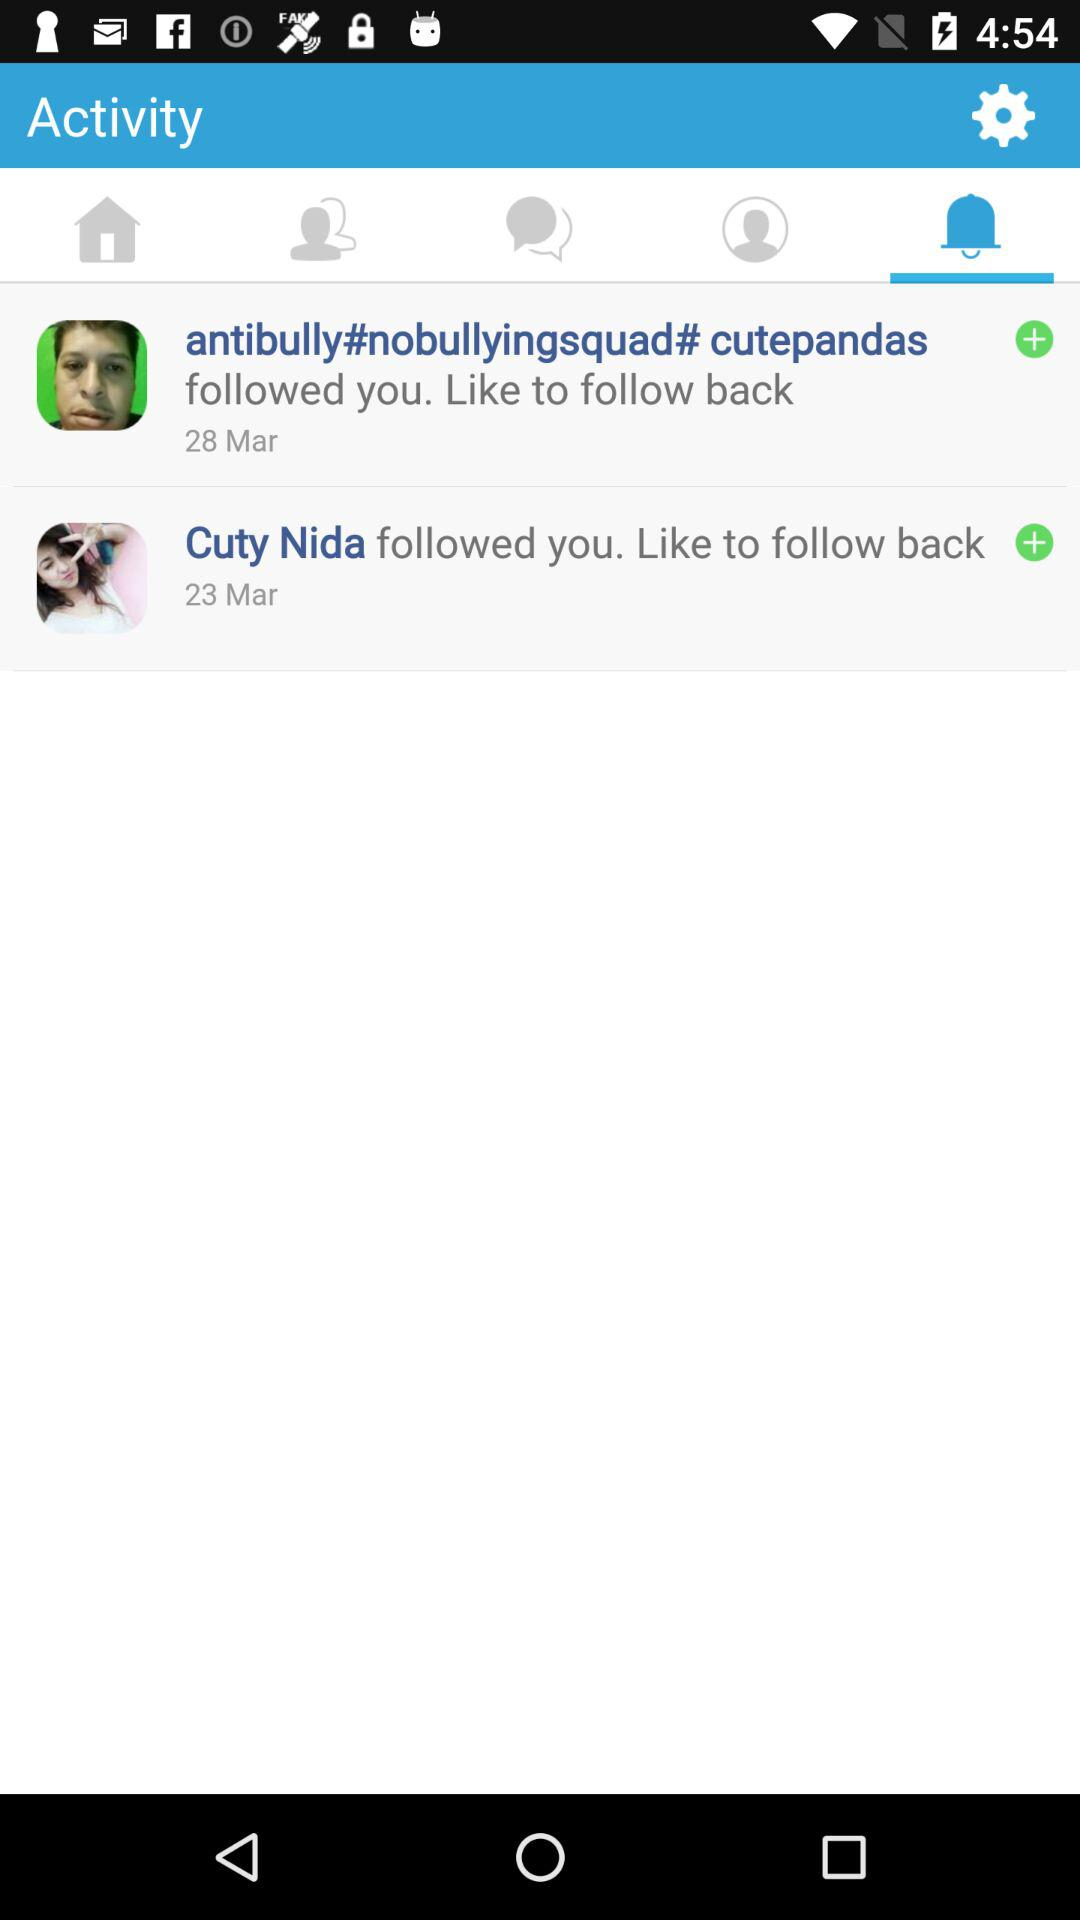On which date did Cuty Nida follow me? Cuty Nida followed you on March 23. 